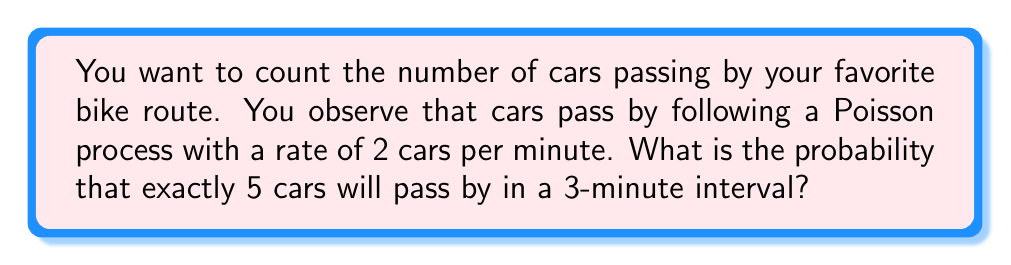Can you solve this math problem? Let's approach this step-by-step:

1) In a Poisson process, the number of events in a fixed time interval follows a Poisson distribution.

2) The Poisson distribution is characterized by its rate parameter λ (lambda), which is the average number of events per unit time multiplied by the time interval.

3) In this case:
   - Rate = 2 cars per minute
   - Time interval = 3 minutes
   - λ = 2 * 3 = 6 cars in 3 minutes

4) The probability mass function for a Poisson distribution is:

   $$P(X = k) = \frac{e^{-λ} λ^k}{k!}$$

   where k is the number of events we're interested in (5 in this case).

5) Substituting our values:

   $$P(X = 5) = \frac{e^{-6} 6^5}{5!}$$

6) Let's calculate this step-by-step:
   
   $$\frac{e^{-6} * 6^5}{5!} = \frac{0.00248 * 7776}{120} = 0.1606$$

7) We can round this to 4 decimal places: 0.1606
Answer: 0.1606 